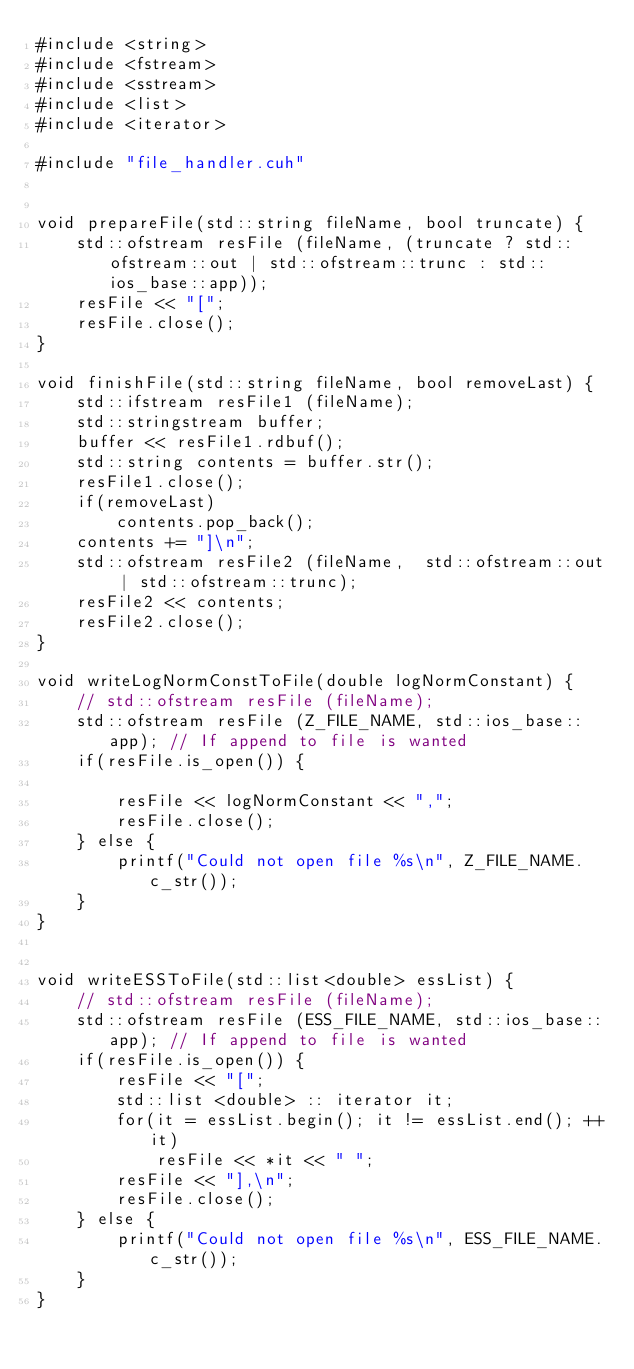<code> <loc_0><loc_0><loc_500><loc_500><_Cuda_>#include <string>
#include <fstream>
#include <sstream>
#include <list>
#include <iterator>

#include "file_handler.cuh"


void prepareFile(std::string fileName, bool truncate) {
    std::ofstream resFile (fileName, (truncate ? std::ofstream::out | std::ofstream::trunc : std::ios_base::app));
    resFile << "[";
    resFile.close();
}

void finishFile(std::string fileName, bool removeLast) {
    std::ifstream resFile1 (fileName);
    std::stringstream buffer;
    buffer << resFile1.rdbuf();
    std::string contents = buffer.str();
    resFile1.close();
    if(removeLast)
        contents.pop_back();
    contents += "]\n";
    std::ofstream resFile2 (fileName,  std::ofstream::out | std::ofstream::trunc);
    resFile2 << contents;
    resFile2.close();
}

void writeLogNormConstToFile(double logNormConstant) {
    // std::ofstream resFile (fileName);
    std::ofstream resFile (Z_FILE_NAME, std::ios_base::app); // If append to file is wanted
    if(resFile.is_open()) {

        resFile << logNormConstant << ",";
        resFile.close();
    } else {
        printf("Could not open file %s\n", Z_FILE_NAME.c_str());
    }
}


void writeESSToFile(std::list<double> essList) {
    // std::ofstream resFile (fileName);
    std::ofstream resFile (ESS_FILE_NAME, std::ios_base::app); // If append to file is wanted
    if(resFile.is_open()) {
        resFile << "[";
        std::list <double> :: iterator it;
        for(it = essList.begin(); it != essList.end(); ++it)
            resFile << *it << " ";
        resFile << "],\n";
        resFile.close();
    } else {
        printf("Could not open file %s\n", ESS_FILE_NAME.c_str());
    }
}
</code> 